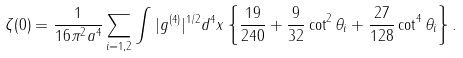<formula> <loc_0><loc_0><loc_500><loc_500>\zeta ( 0 ) = \frac { 1 } { 1 6 \pi ^ { 2 } a ^ { 4 } } \sum _ { i = 1 , 2 } \int | g ^ { ( 4 ) } | ^ { 1 / 2 } d ^ { 4 } x \left \{ \frac { 1 9 } { 2 4 0 } + \frac { 9 } { 3 2 } \cot ^ { 2 } \theta _ { i } + \frac { 2 7 } { 1 2 8 } \cot ^ { 4 } \theta _ { i } \right \} .</formula> 